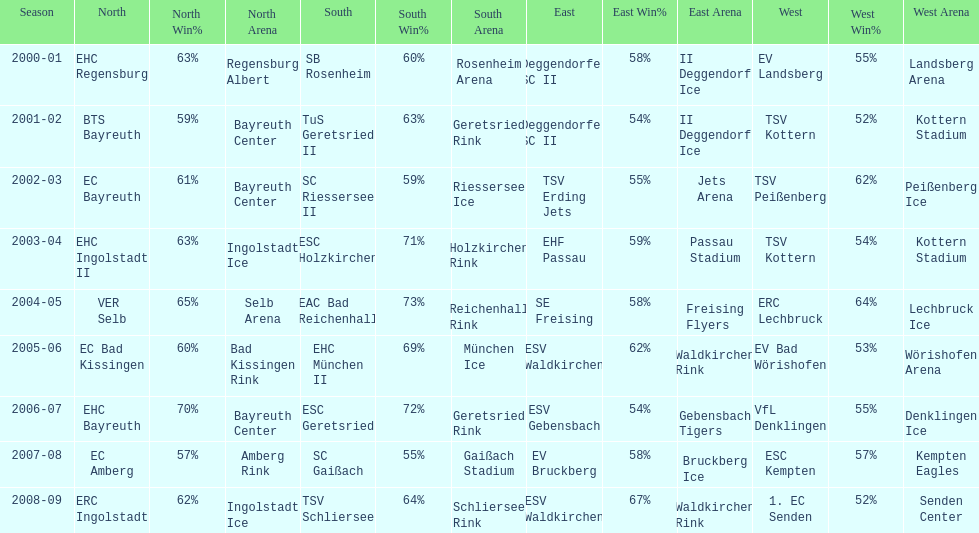Starting with the 2007 - 08 season, does ecs kempten appear in any of the previous years? No. 